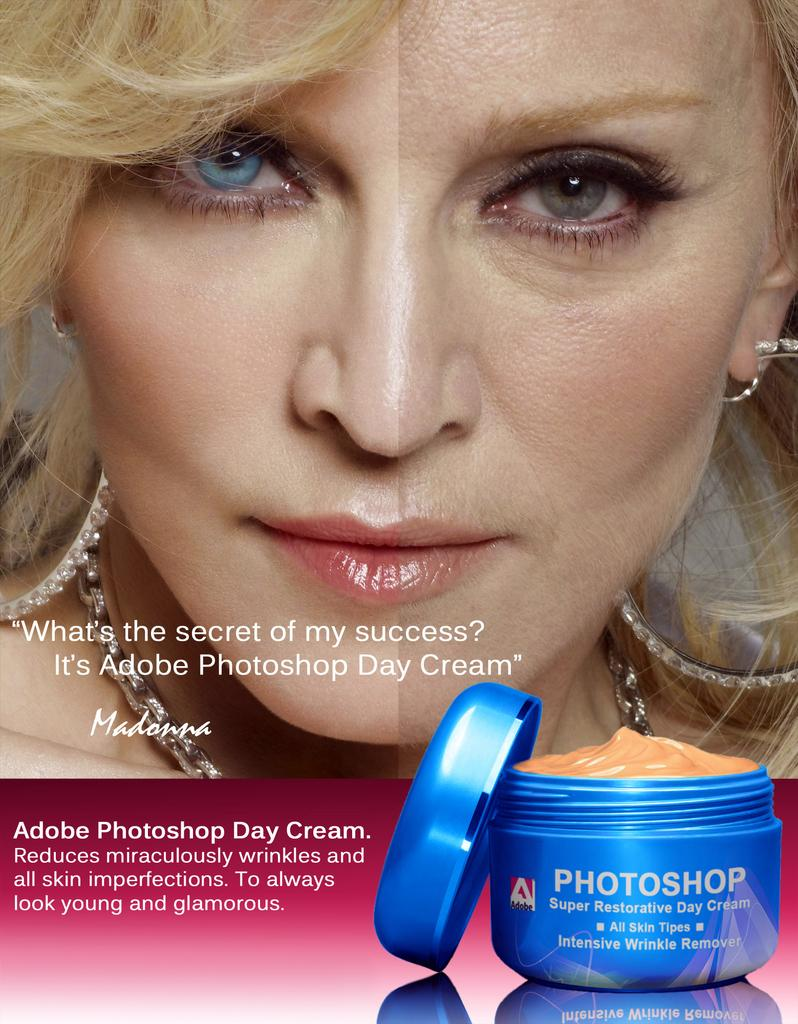<image>
Render a clear and concise summary of the photo. Madonna is shown in a splitscreen in a Photoshop ad. 